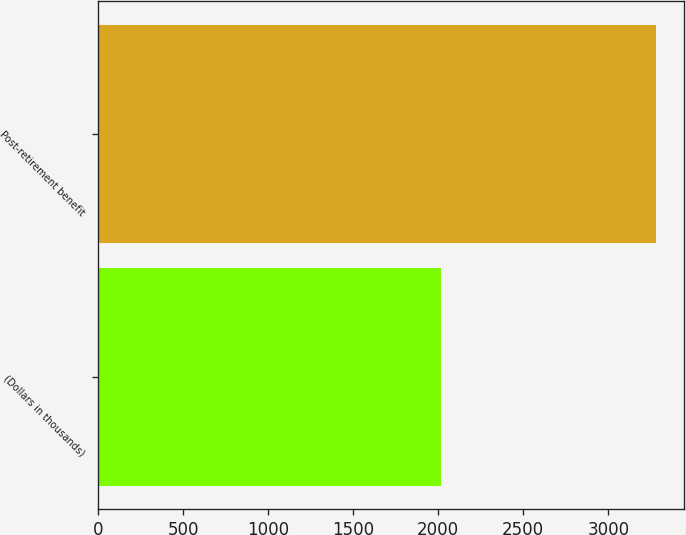Convert chart to OTSL. <chart><loc_0><loc_0><loc_500><loc_500><bar_chart><fcel>(Dollars in thousands)<fcel>Post-retirement benefit<nl><fcel>2015<fcel>3280<nl></chart> 